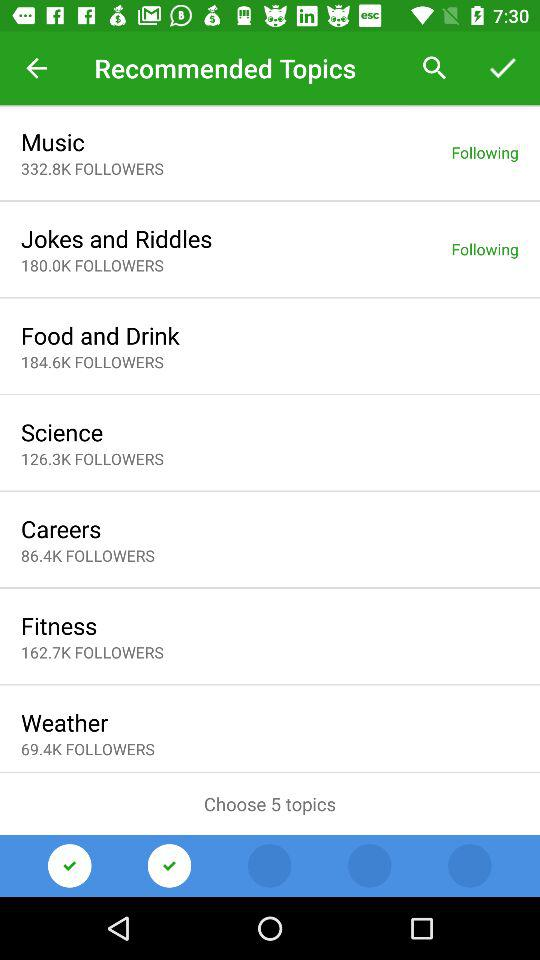What is the maximum number of topics the user can choose? The user can choose 5 topics. 